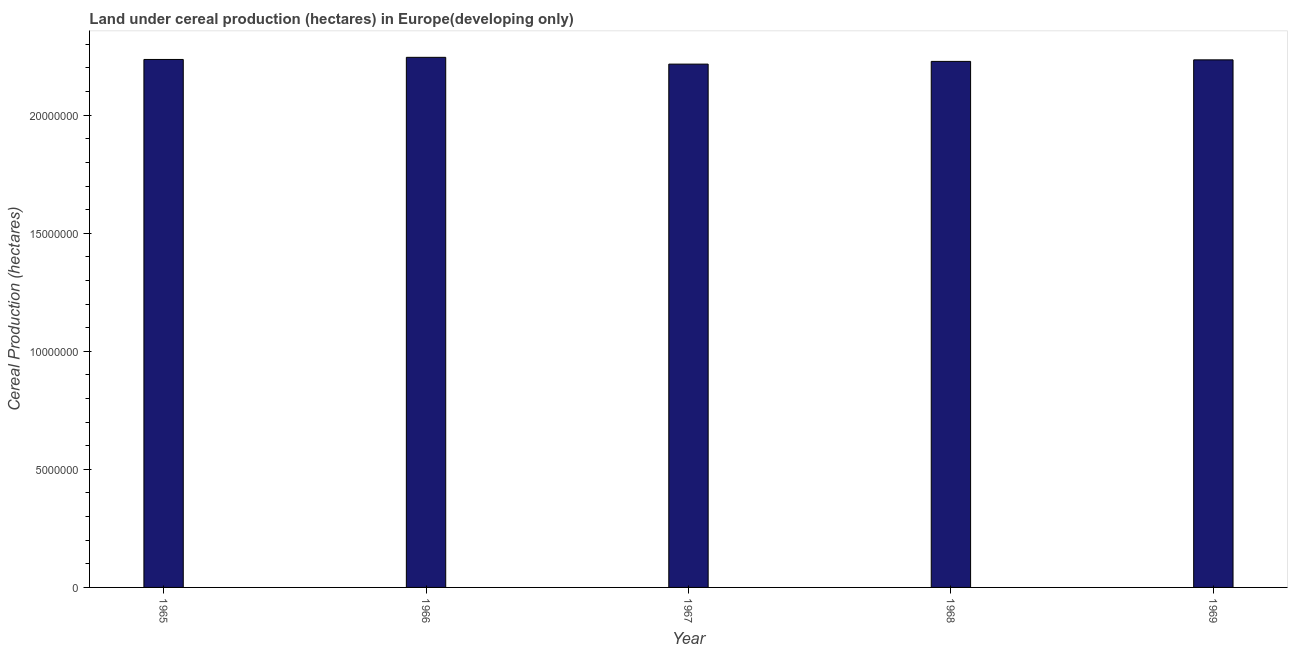Does the graph contain any zero values?
Offer a very short reply. No. Does the graph contain grids?
Provide a succinct answer. No. What is the title of the graph?
Provide a short and direct response. Land under cereal production (hectares) in Europe(developing only). What is the label or title of the X-axis?
Your answer should be very brief. Year. What is the label or title of the Y-axis?
Your answer should be compact. Cereal Production (hectares). What is the land under cereal production in 1967?
Provide a succinct answer. 2.22e+07. Across all years, what is the maximum land under cereal production?
Offer a terse response. 2.25e+07. Across all years, what is the minimum land under cereal production?
Make the answer very short. 2.22e+07. In which year was the land under cereal production maximum?
Ensure brevity in your answer.  1966. In which year was the land under cereal production minimum?
Provide a succinct answer. 1967. What is the sum of the land under cereal production?
Your answer should be very brief. 1.12e+08. What is the difference between the land under cereal production in 1966 and 1969?
Provide a short and direct response. 1.07e+05. What is the average land under cereal production per year?
Offer a very short reply. 2.23e+07. What is the median land under cereal production?
Offer a terse response. 2.23e+07. In how many years, is the land under cereal production greater than 9000000 hectares?
Your response must be concise. 5. What is the ratio of the land under cereal production in 1965 to that in 1969?
Offer a terse response. 1. Is the land under cereal production in 1965 less than that in 1969?
Ensure brevity in your answer.  No. Is the difference between the land under cereal production in 1965 and 1969 greater than the difference between any two years?
Provide a short and direct response. No. What is the difference between the highest and the second highest land under cereal production?
Give a very brief answer. 9.06e+04. Is the sum of the land under cereal production in 1966 and 1968 greater than the maximum land under cereal production across all years?
Offer a very short reply. Yes. What is the difference between the highest and the lowest land under cereal production?
Your answer should be compact. 2.88e+05. In how many years, is the land under cereal production greater than the average land under cereal production taken over all years?
Keep it short and to the point. 3. What is the difference between two consecutive major ticks on the Y-axis?
Make the answer very short. 5.00e+06. What is the Cereal Production (hectares) of 1965?
Your answer should be very brief. 2.24e+07. What is the Cereal Production (hectares) of 1966?
Give a very brief answer. 2.25e+07. What is the Cereal Production (hectares) of 1967?
Your answer should be compact. 2.22e+07. What is the Cereal Production (hectares) of 1968?
Keep it short and to the point. 2.23e+07. What is the Cereal Production (hectares) in 1969?
Ensure brevity in your answer.  2.23e+07. What is the difference between the Cereal Production (hectares) in 1965 and 1966?
Give a very brief answer. -9.06e+04. What is the difference between the Cereal Production (hectares) in 1965 and 1967?
Provide a succinct answer. 1.97e+05. What is the difference between the Cereal Production (hectares) in 1965 and 1968?
Your response must be concise. 8.17e+04. What is the difference between the Cereal Production (hectares) in 1965 and 1969?
Your answer should be very brief. 1.61e+04. What is the difference between the Cereal Production (hectares) in 1966 and 1967?
Offer a terse response. 2.88e+05. What is the difference between the Cereal Production (hectares) in 1966 and 1968?
Give a very brief answer. 1.72e+05. What is the difference between the Cereal Production (hectares) in 1966 and 1969?
Ensure brevity in your answer.  1.07e+05. What is the difference between the Cereal Production (hectares) in 1967 and 1968?
Provide a succinct answer. -1.15e+05. What is the difference between the Cereal Production (hectares) in 1967 and 1969?
Keep it short and to the point. -1.81e+05. What is the difference between the Cereal Production (hectares) in 1968 and 1969?
Offer a very short reply. -6.56e+04. What is the ratio of the Cereal Production (hectares) in 1965 to that in 1966?
Ensure brevity in your answer.  1. What is the ratio of the Cereal Production (hectares) in 1965 to that in 1968?
Give a very brief answer. 1. What is the ratio of the Cereal Production (hectares) in 1965 to that in 1969?
Give a very brief answer. 1. What is the ratio of the Cereal Production (hectares) in 1966 to that in 1968?
Provide a short and direct response. 1.01. What is the ratio of the Cereal Production (hectares) in 1967 to that in 1968?
Your answer should be very brief. 0.99. What is the ratio of the Cereal Production (hectares) in 1967 to that in 1969?
Your answer should be very brief. 0.99. 